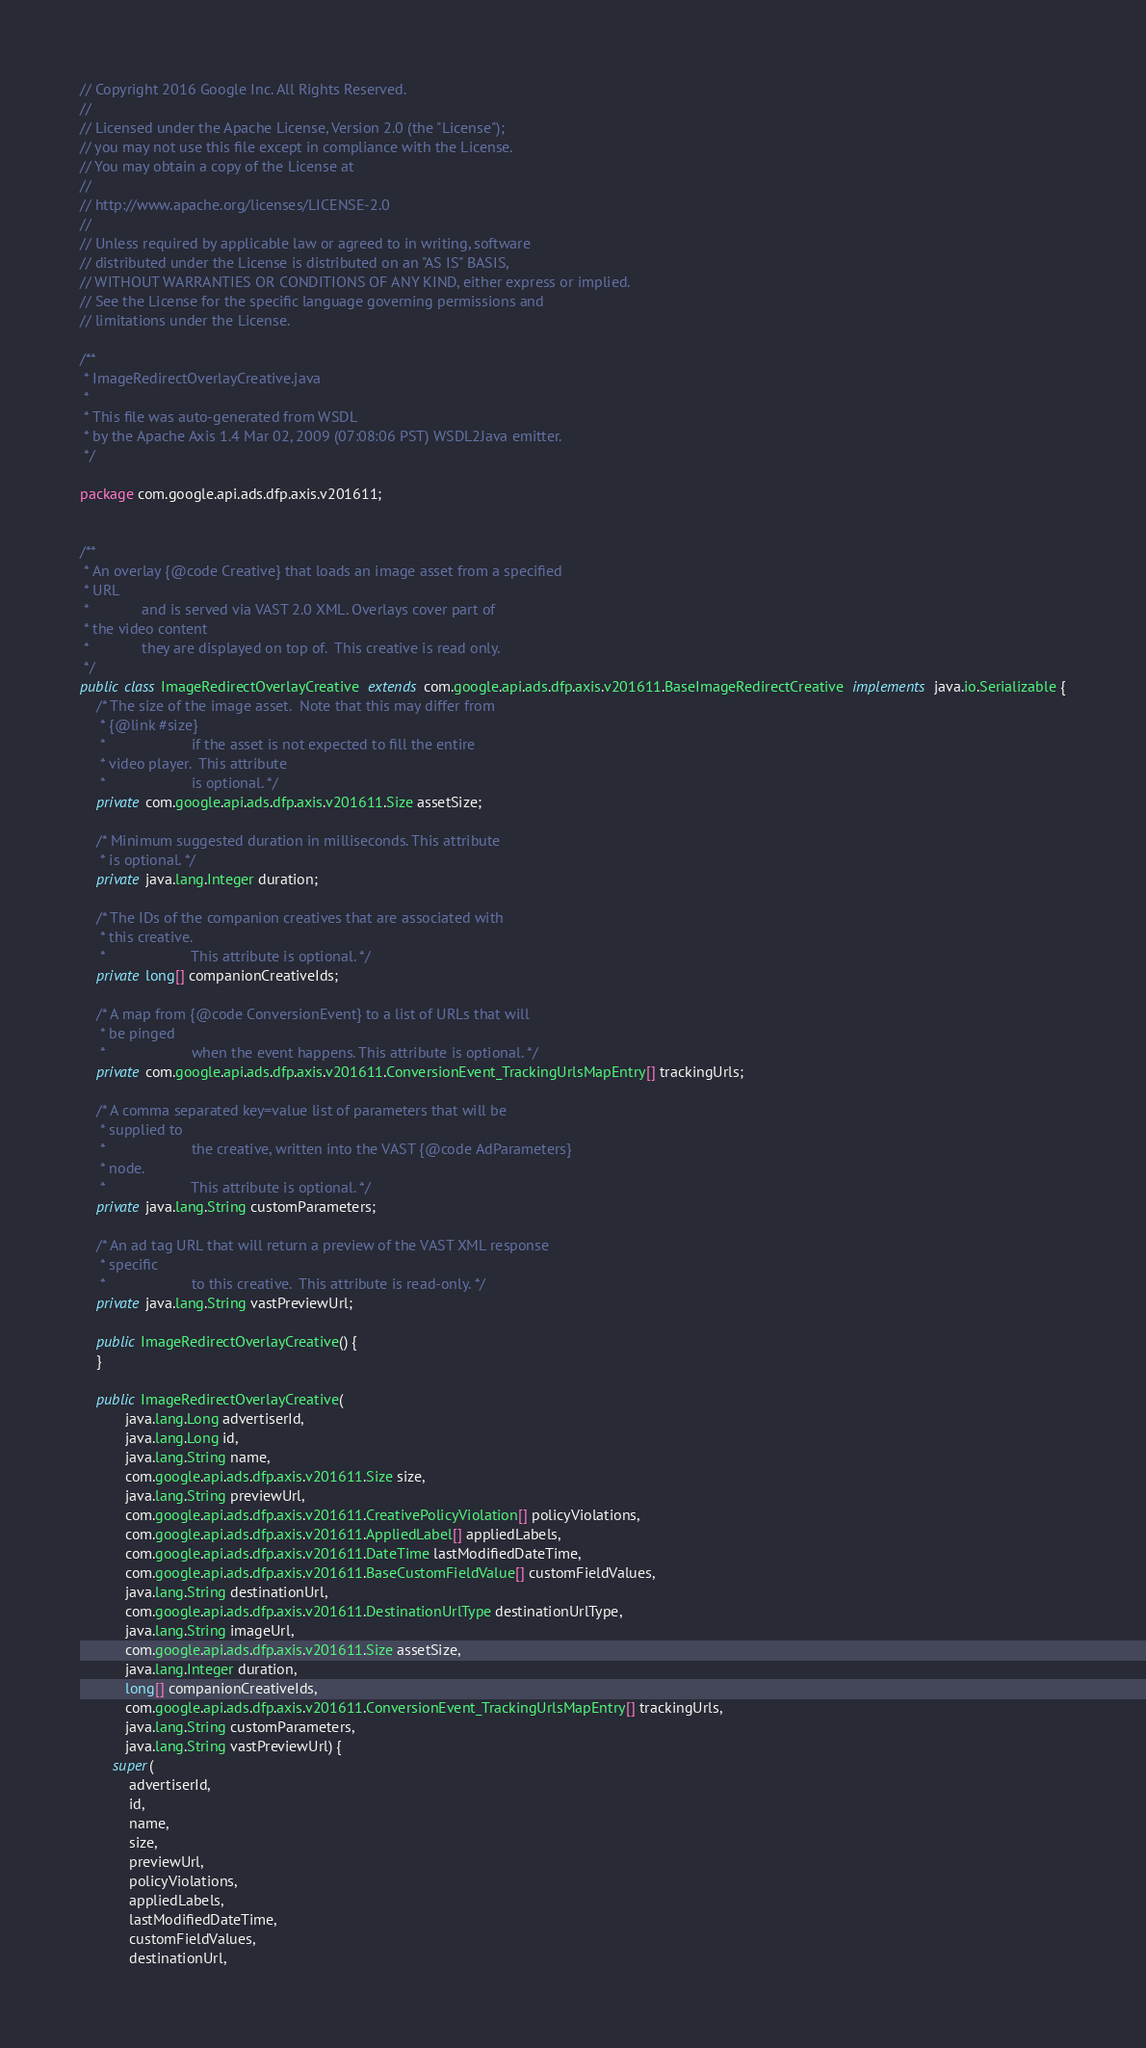<code> <loc_0><loc_0><loc_500><loc_500><_Java_>// Copyright 2016 Google Inc. All Rights Reserved.
//
// Licensed under the Apache License, Version 2.0 (the "License");
// you may not use this file except in compliance with the License.
// You may obtain a copy of the License at
//
// http://www.apache.org/licenses/LICENSE-2.0
//
// Unless required by applicable law or agreed to in writing, software
// distributed under the License is distributed on an "AS IS" BASIS,
// WITHOUT WARRANTIES OR CONDITIONS OF ANY KIND, either express or implied.
// See the License for the specific language governing permissions and
// limitations under the License.

/**
 * ImageRedirectOverlayCreative.java
 *
 * This file was auto-generated from WSDL
 * by the Apache Axis 1.4 Mar 02, 2009 (07:08:06 PST) WSDL2Java emitter.
 */

package com.google.api.ads.dfp.axis.v201611;


/**
 * An overlay {@code Creative} that loads an image asset from a specified
 * URL
 *             and is served via VAST 2.0 XML. Overlays cover part of
 * the video content
 *             they are displayed on top of.  This creative is read only.
 */
public class ImageRedirectOverlayCreative  extends com.google.api.ads.dfp.axis.v201611.BaseImageRedirectCreative  implements java.io.Serializable {
    /* The size of the image asset.  Note that this may differ from
     * {@link #size}
     *                     if the asset is not expected to fill the entire
     * video player.  This attribute
     *                     is optional. */
    private com.google.api.ads.dfp.axis.v201611.Size assetSize;

    /* Minimum suggested duration in milliseconds. This attribute
     * is optional. */
    private java.lang.Integer duration;

    /* The IDs of the companion creatives that are associated with
     * this creative.
     *                     This attribute is optional. */
    private long[] companionCreativeIds;

    /* A map from {@code ConversionEvent} to a list of URLs that will
     * be pinged
     *                     when the event happens. This attribute is optional. */
    private com.google.api.ads.dfp.axis.v201611.ConversionEvent_TrackingUrlsMapEntry[] trackingUrls;

    /* A comma separated key=value list of parameters that will be
     * supplied to
     *                     the creative, written into the VAST {@code AdParameters}
     * node.
     *                     This attribute is optional. */
    private java.lang.String customParameters;

    /* An ad tag URL that will return a preview of the VAST XML response
     * specific
     *                     to this creative.  This attribute is read-only. */
    private java.lang.String vastPreviewUrl;

    public ImageRedirectOverlayCreative() {
    }

    public ImageRedirectOverlayCreative(
           java.lang.Long advertiserId,
           java.lang.Long id,
           java.lang.String name,
           com.google.api.ads.dfp.axis.v201611.Size size,
           java.lang.String previewUrl,
           com.google.api.ads.dfp.axis.v201611.CreativePolicyViolation[] policyViolations,
           com.google.api.ads.dfp.axis.v201611.AppliedLabel[] appliedLabels,
           com.google.api.ads.dfp.axis.v201611.DateTime lastModifiedDateTime,
           com.google.api.ads.dfp.axis.v201611.BaseCustomFieldValue[] customFieldValues,
           java.lang.String destinationUrl,
           com.google.api.ads.dfp.axis.v201611.DestinationUrlType destinationUrlType,
           java.lang.String imageUrl,
           com.google.api.ads.dfp.axis.v201611.Size assetSize,
           java.lang.Integer duration,
           long[] companionCreativeIds,
           com.google.api.ads.dfp.axis.v201611.ConversionEvent_TrackingUrlsMapEntry[] trackingUrls,
           java.lang.String customParameters,
           java.lang.String vastPreviewUrl) {
        super(
            advertiserId,
            id,
            name,
            size,
            previewUrl,
            policyViolations,
            appliedLabels,
            lastModifiedDateTime,
            customFieldValues,
            destinationUrl,</code> 